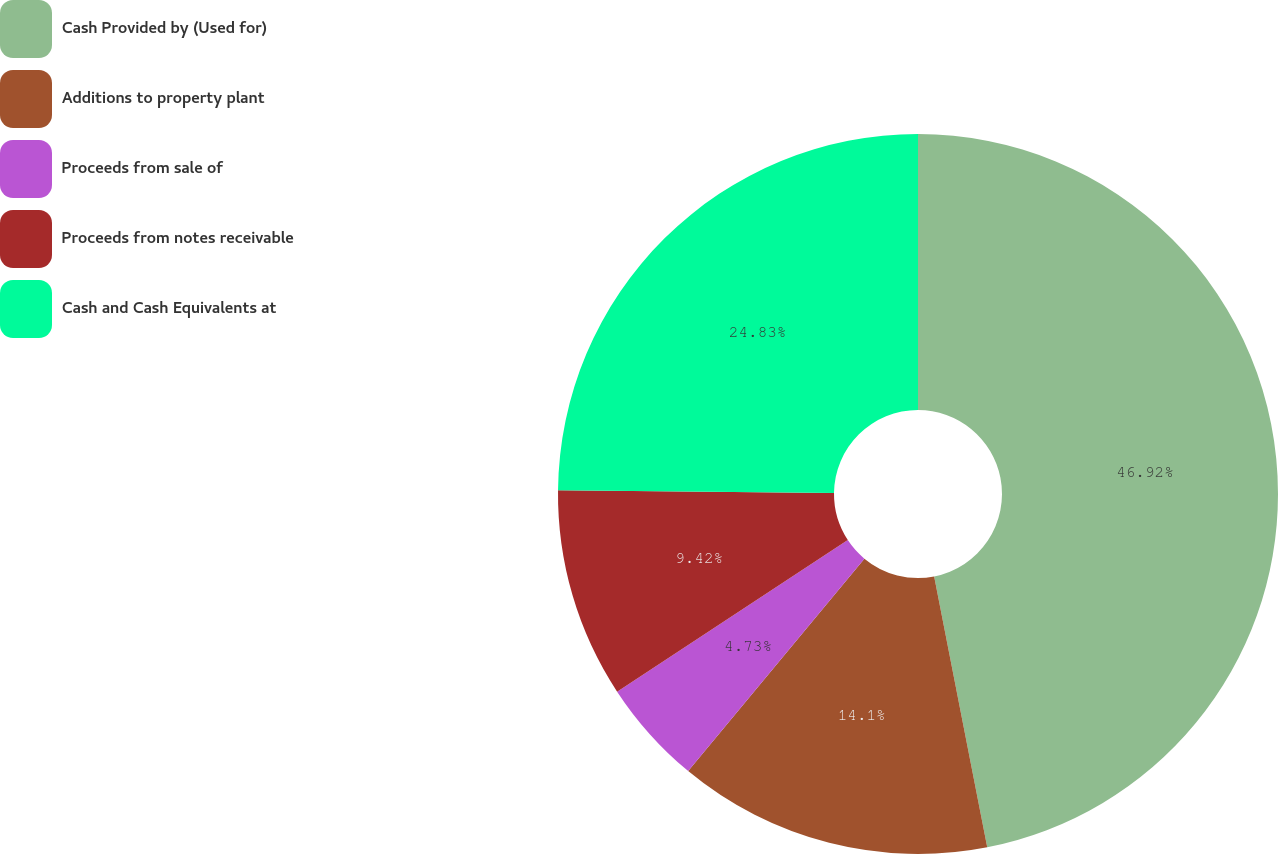Convert chart. <chart><loc_0><loc_0><loc_500><loc_500><pie_chart><fcel>Cash Provided by (Used for)<fcel>Additions to property plant<fcel>Proceeds from sale of<fcel>Proceeds from notes receivable<fcel>Cash and Cash Equivalents at<nl><fcel>46.92%<fcel>14.1%<fcel>4.73%<fcel>9.42%<fcel>24.83%<nl></chart> 